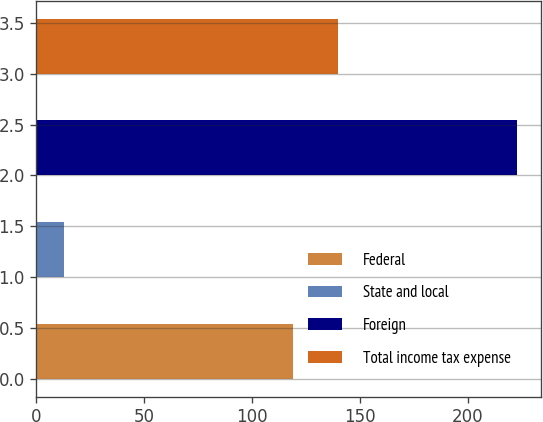Convert chart. <chart><loc_0><loc_0><loc_500><loc_500><bar_chart><fcel>Federal<fcel>State and local<fcel>Foreign<fcel>Total income tax expense<nl><fcel>119<fcel>13<fcel>223<fcel>140<nl></chart> 